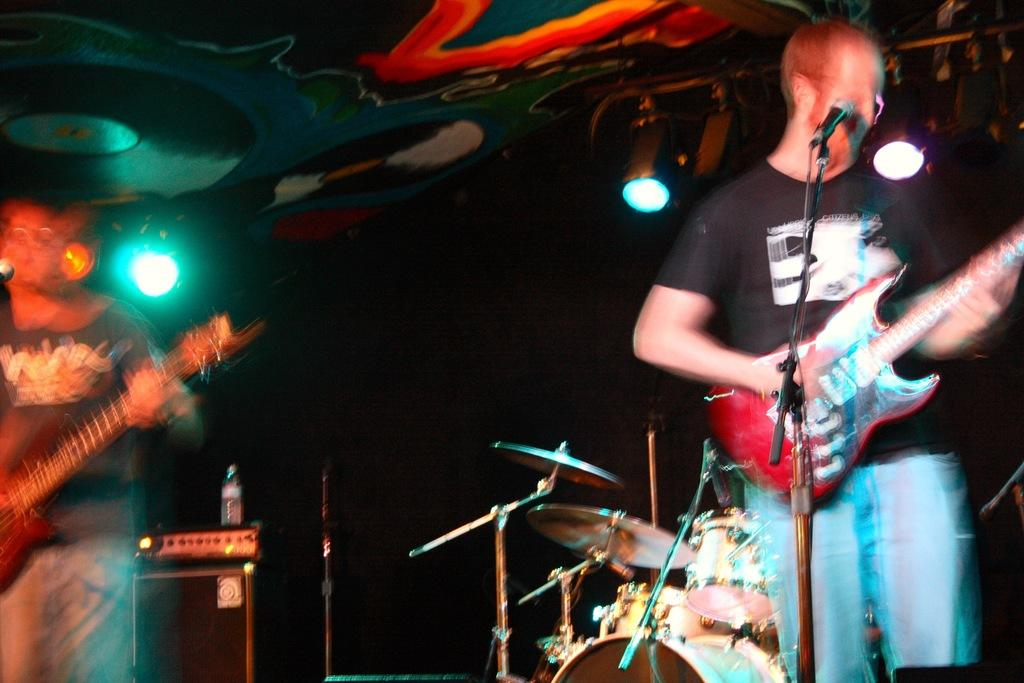How many people are in the image? There are two persons in the image. What are the two persons doing in the image? The two persons are playing musical instruments. What type of bone can be seen in the image? There is no bone present in the image; the two persons are playing musical instruments. What type of jeans are the persons wearing in the image? The provided facts do not mention any clothing, so we cannot determine if the persons are wearing jeans or any other type of clothing. 